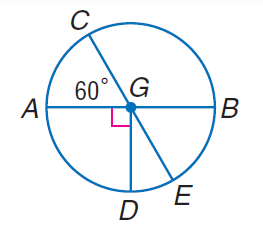Answer the mathemtical geometry problem and directly provide the correct option letter.
Question: Find m \angle C G D.
Choices: A: 30 B: 60 C: 150 D: 210 C 